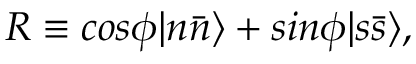Convert formula to latex. <formula><loc_0><loc_0><loc_500><loc_500>R \equiv \cos \phi | n \bar { n } \rangle + \sin \phi | s \bar { s } \rangle ,</formula> 